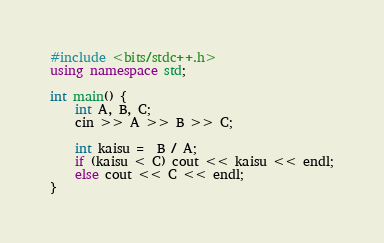Convert code to text. <code><loc_0><loc_0><loc_500><loc_500><_C++_>#include <bits/stdc++.h>
using namespace std;

int main() {
    int A, B, C;
    cin >> A >> B >> C;
    
    int kaisu =  B / A;
    if (kaisu < C) cout << kaisu << endl;
    else cout << C << endl;
}
</code> 